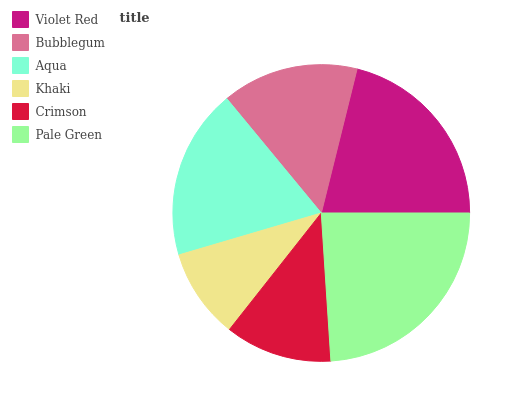Is Khaki the minimum?
Answer yes or no. Yes. Is Pale Green the maximum?
Answer yes or no. Yes. Is Bubblegum the minimum?
Answer yes or no. No. Is Bubblegum the maximum?
Answer yes or no. No. Is Violet Red greater than Bubblegum?
Answer yes or no. Yes. Is Bubblegum less than Violet Red?
Answer yes or no. Yes. Is Bubblegum greater than Violet Red?
Answer yes or no. No. Is Violet Red less than Bubblegum?
Answer yes or no. No. Is Aqua the high median?
Answer yes or no. Yes. Is Bubblegum the low median?
Answer yes or no. Yes. Is Pale Green the high median?
Answer yes or no. No. Is Khaki the low median?
Answer yes or no. No. 